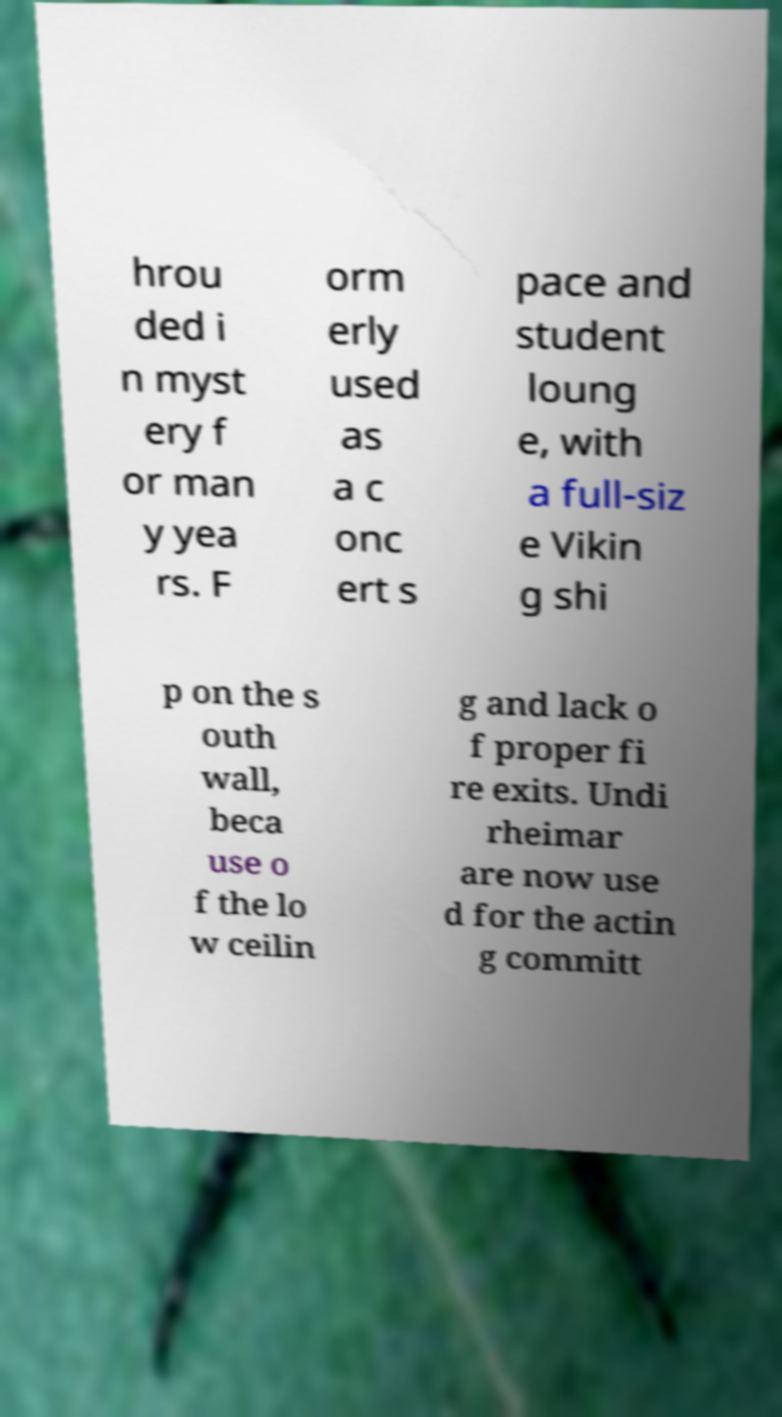Please read and relay the text visible in this image. What does it say? hrou ded i n myst ery f or man y yea rs. F orm erly used as a c onc ert s pace and student loung e, with a full-siz e Vikin g shi p on the s outh wall, beca use o f the lo w ceilin g and lack o f proper fi re exits. Undi rheimar are now use d for the actin g committ 